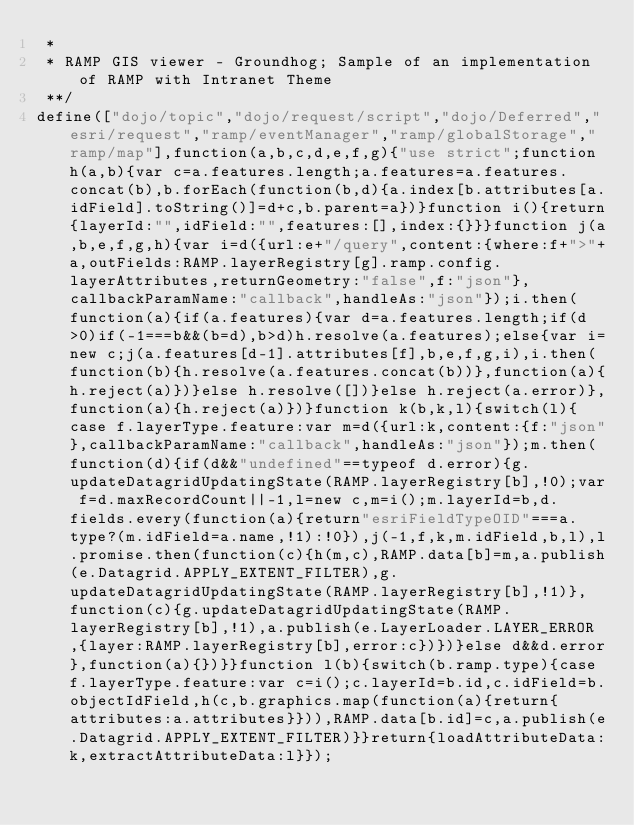<code> <loc_0><loc_0><loc_500><loc_500><_JavaScript_> * 
 * RAMP GIS viewer - Groundhog; Sample of an implementation of RAMP with Intranet Theme 
 **/
define(["dojo/topic","dojo/request/script","dojo/Deferred","esri/request","ramp/eventManager","ramp/globalStorage","ramp/map"],function(a,b,c,d,e,f,g){"use strict";function h(a,b){var c=a.features.length;a.features=a.features.concat(b),b.forEach(function(b,d){a.index[b.attributes[a.idField].toString()]=d+c,b.parent=a})}function i(){return{layerId:"",idField:"",features:[],index:{}}}function j(a,b,e,f,g,h){var i=d({url:e+"/query",content:{where:f+">"+a,outFields:RAMP.layerRegistry[g].ramp.config.layerAttributes,returnGeometry:"false",f:"json"},callbackParamName:"callback",handleAs:"json"});i.then(function(a){if(a.features){var d=a.features.length;if(d>0)if(-1===b&&(b=d),b>d)h.resolve(a.features);else{var i=new c;j(a.features[d-1].attributes[f],b,e,f,g,i),i.then(function(b){h.resolve(a.features.concat(b))},function(a){h.reject(a)})}else h.resolve([])}else h.reject(a.error)},function(a){h.reject(a)})}function k(b,k,l){switch(l){case f.layerType.feature:var m=d({url:k,content:{f:"json"},callbackParamName:"callback",handleAs:"json"});m.then(function(d){if(d&&"undefined"==typeof d.error){g.updateDatagridUpdatingState(RAMP.layerRegistry[b],!0);var f=d.maxRecordCount||-1,l=new c,m=i();m.layerId=b,d.fields.every(function(a){return"esriFieldTypeOID"===a.type?(m.idField=a.name,!1):!0}),j(-1,f,k,m.idField,b,l),l.promise.then(function(c){h(m,c),RAMP.data[b]=m,a.publish(e.Datagrid.APPLY_EXTENT_FILTER),g.updateDatagridUpdatingState(RAMP.layerRegistry[b],!1)},function(c){g.updateDatagridUpdatingState(RAMP.layerRegistry[b],!1),a.publish(e.LayerLoader.LAYER_ERROR,{layer:RAMP.layerRegistry[b],error:c})})}else d&&d.error},function(a){})}}function l(b){switch(b.ramp.type){case f.layerType.feature:var c=i();c.layerId=b.id,c.idField=b.objectIdField,h(c,b.graphics.map(function(a){return{attributes:a.attributes}})),RAMP.data[b.id]=c,a.publish(e.Datagrid.APPLY_EXTENT_FILTER)}}return{loadAttributeData:k,extractAttributeData:l}});</code> 